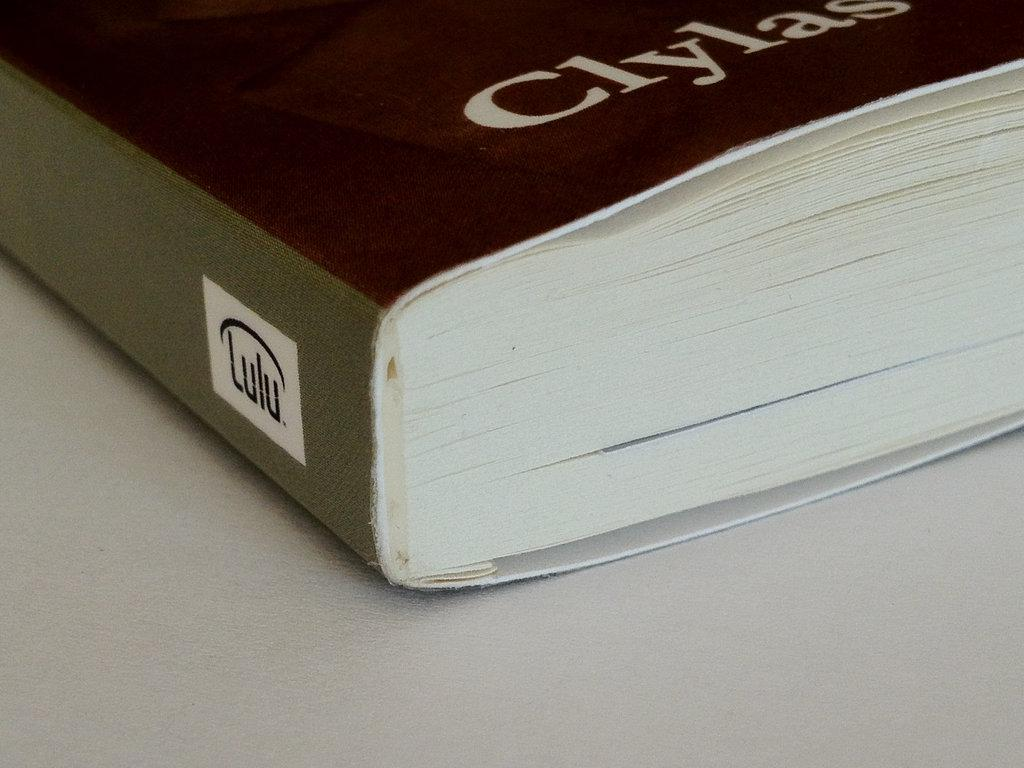<image>
Summarize the visual content of the image. On the spine of a paperback book is the word Lulu. 